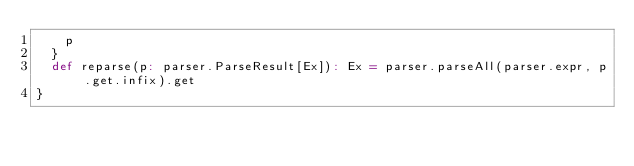Convert code to text. <code><loc_0><loc_0><loc_500><loc_500><_Scala_>    p
  }
  def reparse(p: parser.ParseResult[Ex]): Ex = parser.parseAll(parser.expr, p.get.infix).get
}
</code> 